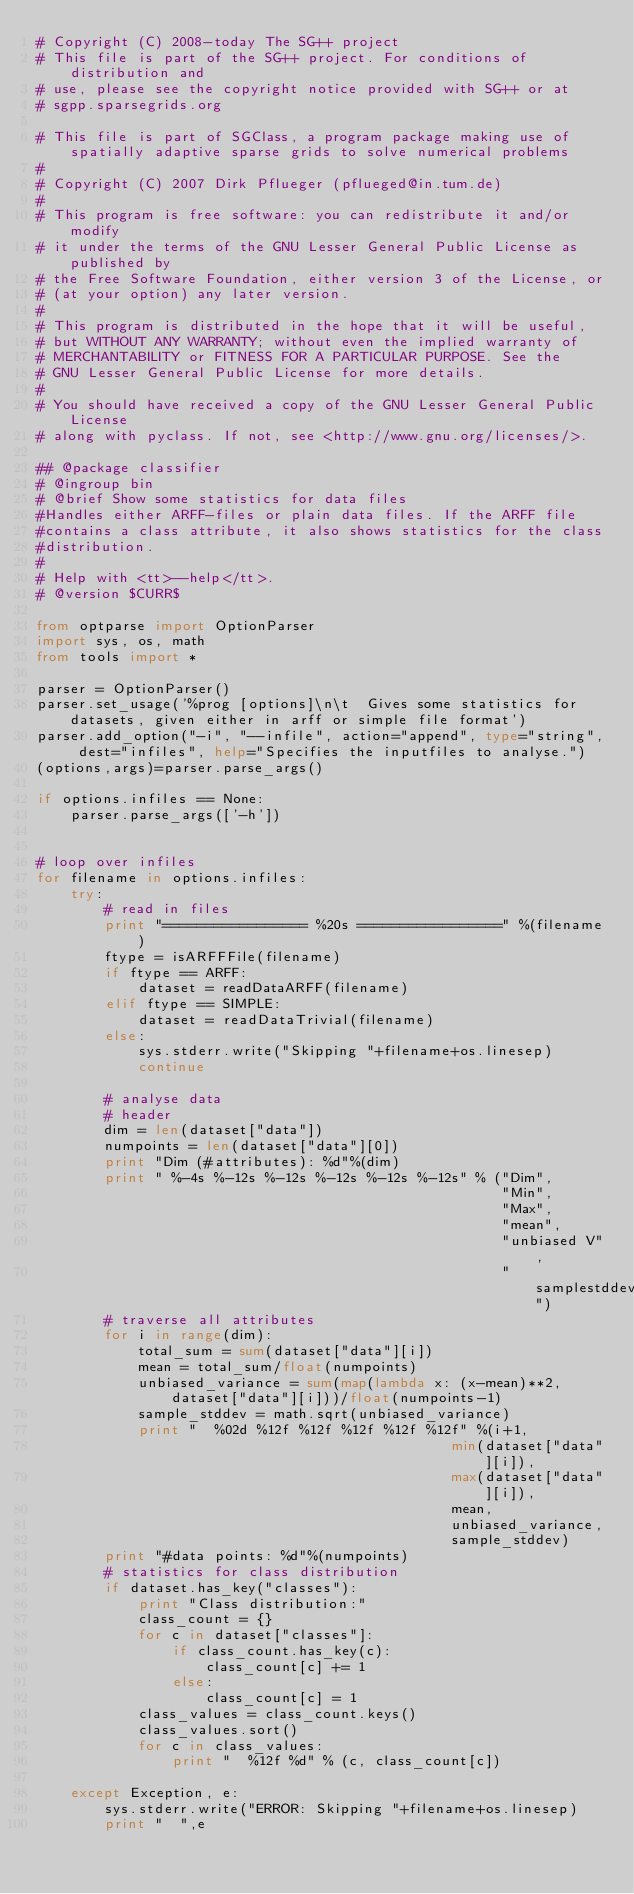<code> <loc_0><loc_0><loc_500><loc_500><_Python_># Copyright (C) 2008-today The SG++ project
# This file is part of the SG++ project. For conditions of distribution and
# use, please see the copyright notice provided with SG++ or at 
# sgpp.sparsegrids.org

# This file is part of SGClass, a program package making use of spatially adaptive sparse grids to solve numerical problems
#
# Copyright (C) 2007 Dirk Pflueger (pflueged@in.tum.de)
# 
# This program is free software: you can redistribute it and/or modify
# it under the terms of the GNU Lesser General Public License as published by
# the Free Software Foundation, either version 3 of the License, or
# (at your option) any later version.
# 
# This program is distributed in the hope that it will be useful,
# but WITHOUT ANY WARRANTY; without even the implied warranty of
# MERCHANTABILITY or FITNESS FOR A PARTICULAR PURPOSE. See the
# GNU Lesser General Public License for more details.
# 
# You should have received a copy of the GNU Lesser General Public License
# along with pyclass. If not, see <http://www.gnu.org/licenses/>.

## @package classifier
# @ingroup bin
# @brief Show some statistics for data files
#Handles either ARFF-files or plain data files. If the ARFF file
#contains a class attribute, it also shows statistics for the class
#distribution. 
#
# Help with <tt>--help</tt>.
# @version $CURR$

from optparse import OptionParser
import sys, os, math
from tools import *

parser = OptionParser()
parser.set_usage('%prog [options]\n\t  Gives some statistics for datasets, given either in arff or simple file format')
parser.add_option("-i", "--infile", action="append", type="string", dest="infiles", help="Specifies the inputfiles to analyse.")
(options,args)=parser.parse_args()

if options.infiles == None:
    parser.parse_args(['-h'])
	

# loop over infiles
for filename in options.infiles:
    try:
        # read in files
        print "================= %20s =================" %(filename)
        ftype = isARFFFile(filename)
        if ftype == ARFF:
            dataset = readDataARFF(filename)
        elif ftype == SIMPLE:
            dataset = readDataTrivial(filename)
        else:
            sys.stderr.write("Skipping "+filename+os.linesep)
            continue

        # analyse data
        # header
        dim = len(dataset["data"])
        numpoints = len(dataset["data"][0])
        print "Dim (#attributes): %d"%(dim)
        print " %-4s %-12s %-12s %-12s %-12s %-12s" % ("Dim",
                                                       "Min",
                                                       "Max",
                                                       "mean",
                                                       "unbiased V",
                                                       "samplestddev")
        # traverse all attributes
        for i in range(dim):
            total_sum = sum(dataset["data"][i])
            mean = total_sum/float(numpoints)
            unbiased_variance = sum(map(lambda x: (x-mean)**2, dataset["data"][i]))/float(numpoints-1)
            sample_stddev = math.sqrt(unbiased_variance)
            print "  %02d %12f %12f %12f %12f %12f" %(i+1,
                                                 min(dataset["data"][i]),
                                                 max(dataset["data"][i]),
                                                 mean,
                                                 unbiased_variance,
                                                 sample_stddev)
        print "#data points: %d"%(numpoints)
        # statistics for class distribution
        if dataset.has_key("classes"):
            print "Class distribution:"
            class_count = {}
            for c in dataset["classes"]:
                if class_count.has_key(c):
                    class_count[c] += 1
                else:
                    class_count[c] = 1
            class_values = class_count.keys()
            class_values.sort()
            for c in class_values:
                print "  %12f %d" % (c, class_count[c])

    except Exception, e:
        sys.stderr.write("ERROR: Skipping "+filename+os.linesep)
        print "  ",e</code> 